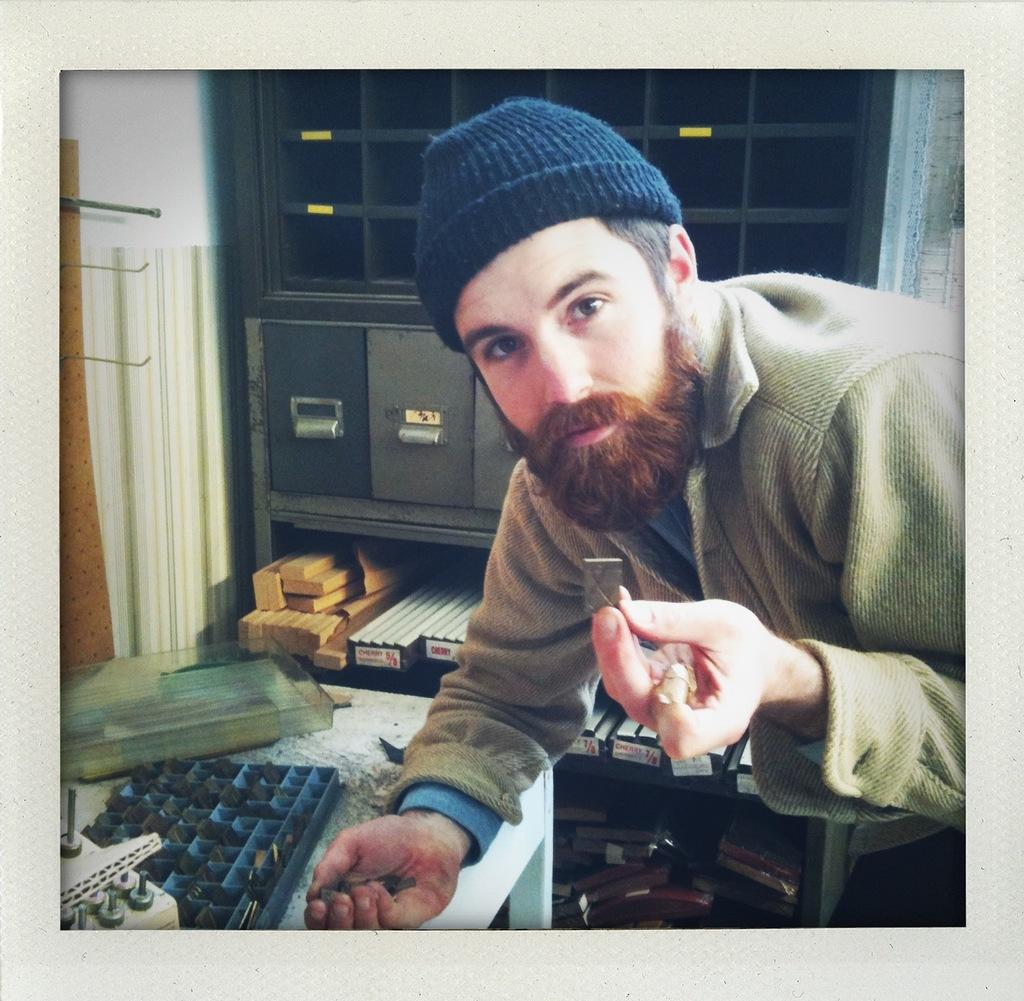Who is present in the image? There is a person in the image. What is the person wearing on their head? The person is wearing a cap. What is the person holding in their hands? The person is holding objects in their hands. What can be seen on the table in the image? There is a device on the table in the image. What other objects are visible in the image? There are additional objects in the image. Are there any giants visible in the image? No, there are no giants present in the image. What type of nest can be seen in the image? There is no nest present in the image. 